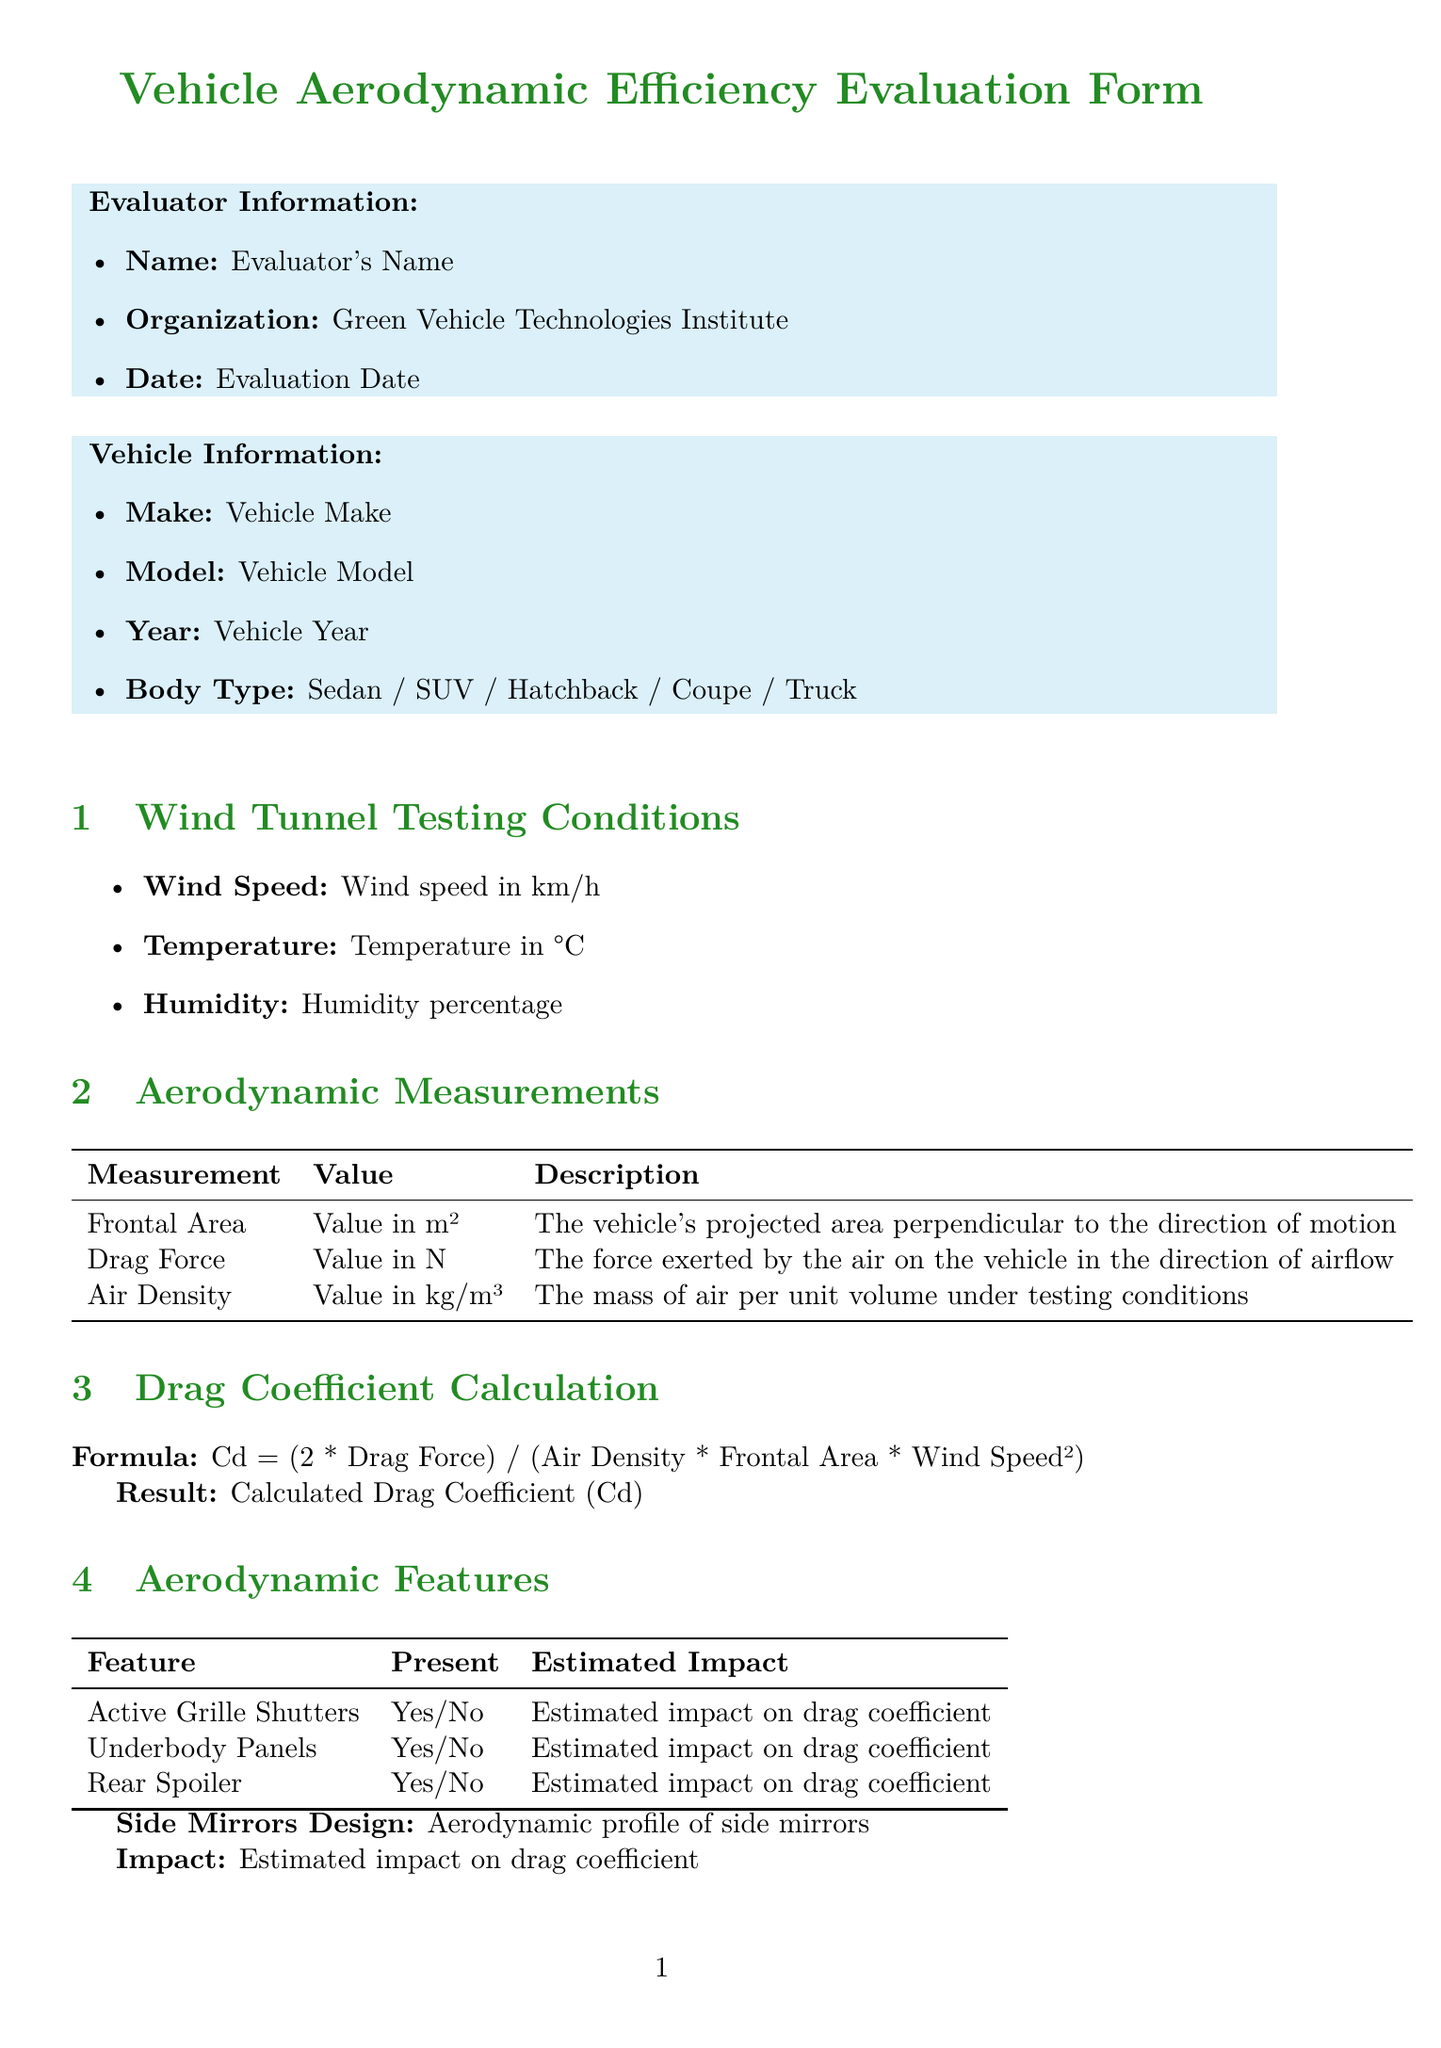what is the evaluator's name? The document specifies a placeholder for the evaluator's name.
Answer: Evaluator's Name what is the make of the vehicle? The document specifies a placeholder for the vehicle make.
Answer: Vehicle Make what is the formula used for drag coefficient calculation? The drag coefficient calculation section includes the specific formula.
Answer: Cd = (2 * Drag Force) / (Air Density * Frontal Area * Wind Speed²) how many aerodynamic features are listed? The aerodynamic features section lists four features in a table format.
Answer: 4 what is the estimated annual CO2 reduction in kg? The environmental impact section includes an estimation for CO2 reduction.
Answer: Estimated annual CO2 reduction in kg how many recommendations are provided for aerodynamic improvements? The recommendations section includes three specific suggestions.
Answer: 3 what is the body type listed for the vehicle? The vehicle information section provides a choice of body types.
Answer: Sedan / SUV / Hatchback / Coupe / Truck what is the overall aerodynamic efficiency rating scale? The conclusion section provides the rating scale for overall aerodynamic efficiency.
Answer: Rating on a scale of 1-10 what is the suggested action for the roof line? A recommendation listed in the document suggests an action regarding roof design.
Answer: Consider a more tapered roof design to improve air separation 